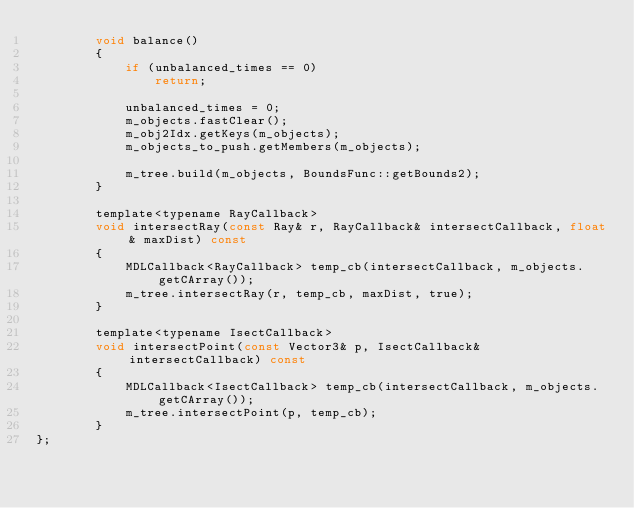<code> <loc_0><loc_0><loc_500><loc_500><_C_>        void balance()
        {
            if (unbalanced_times == 0)
                return;

            unbalanced_times = 0;
            m_objects.fastClear();
            m_obj2Idx.getKeys(m_objects);
            m_objects_to_push.getMembers(m_objects);

            m_tree.build(m_objects, BoundsFunc::getBounds2);
        }

        template<typename RayCallback>
        void intersectRay(const Ray& r, RayCallback& intersectCallback, float& maxDist) const
        {
            MDLCallback<RayCallback> temp_cb(intersectCallback, m_objects.getCArray());
            m_tree.intersectRay(r, temp_cb, maxDist, true);
        }

        template<typename IsectCallback>
        void intersectPoint(const Vector3& p, IsectCallback& intersectCallback) const
        {
            MDLCallback<IsectCallback> temp_cb(intersectCallback, m_objects.getCArray());
            m_tree.intersectPoint(p, temp_cb);
        }
};
</code> 